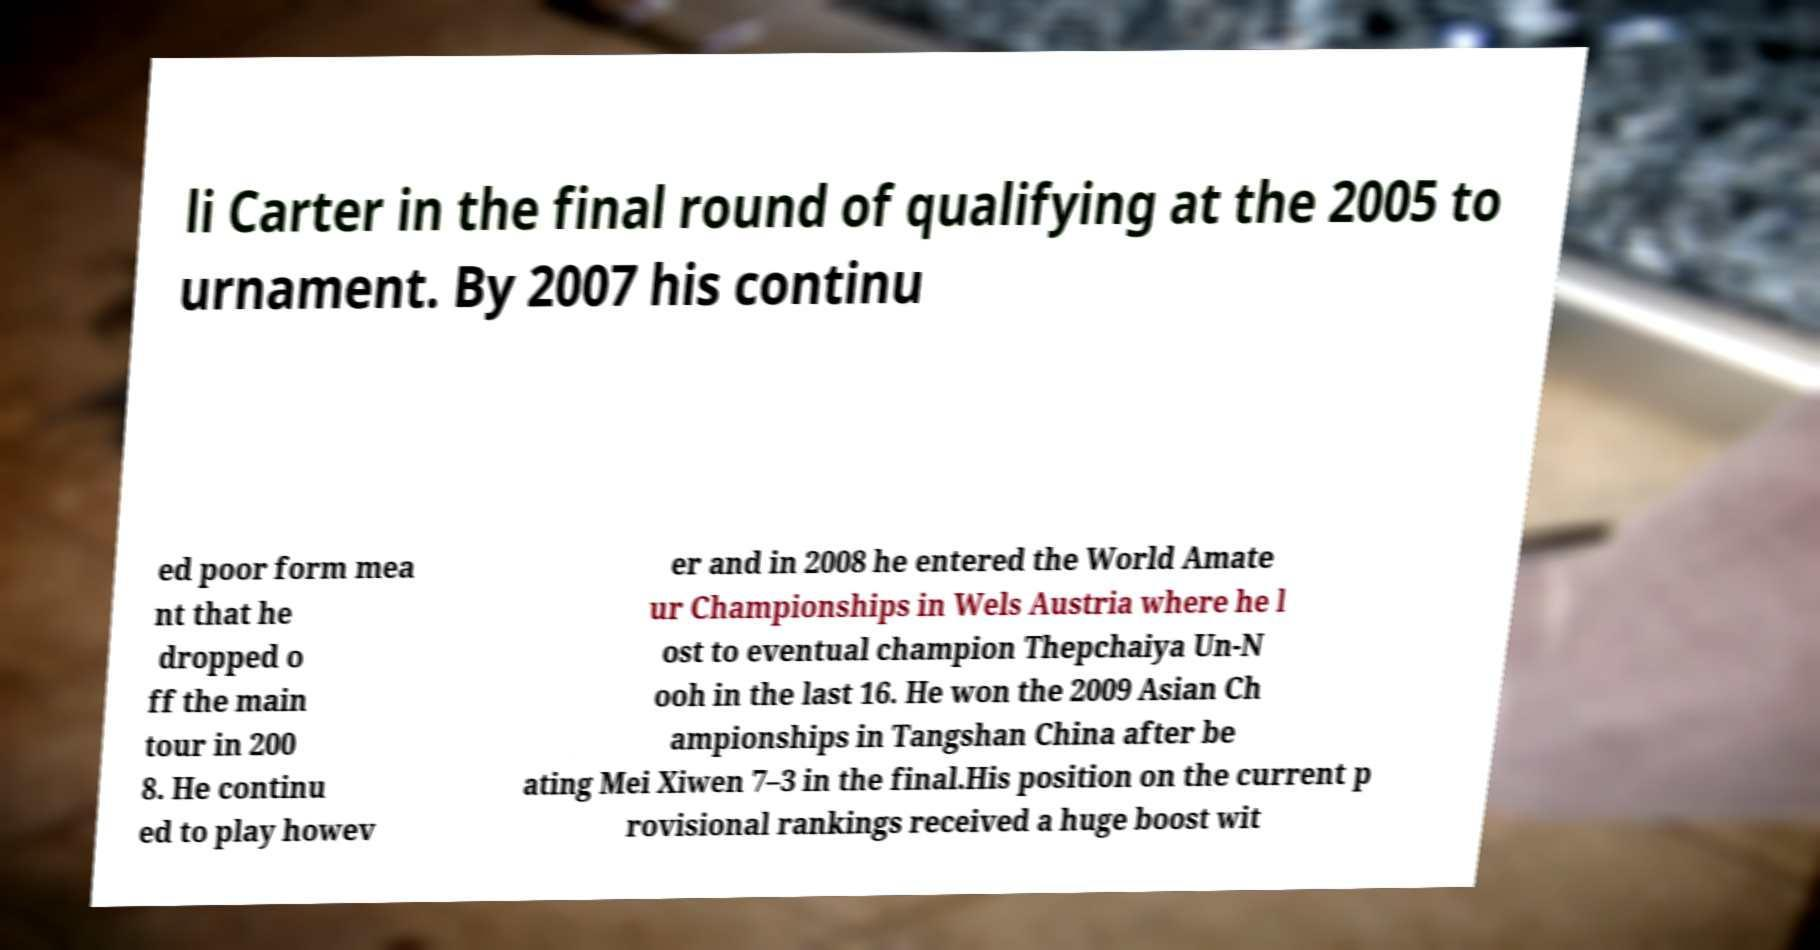Could you extract and type out the text from this image? li Carter in the final round of qualifying at the 2005 to urnament. By 2007 his continu ed poor form mea nt that he dropped o ff the main tour in 200 8. He continu ed to play howev er and in 2008 he entered the World Amate ur Championships in Wels Austria where he l ost to eventual champion Thepchaiya Un-N ooh in the last 16. He won the 2009 Asian Ch ampionships in Tangshan China after be ating Mei Xiwen 7–3 in the final.His position on the current p rovisional rankings received a huge boost wit 